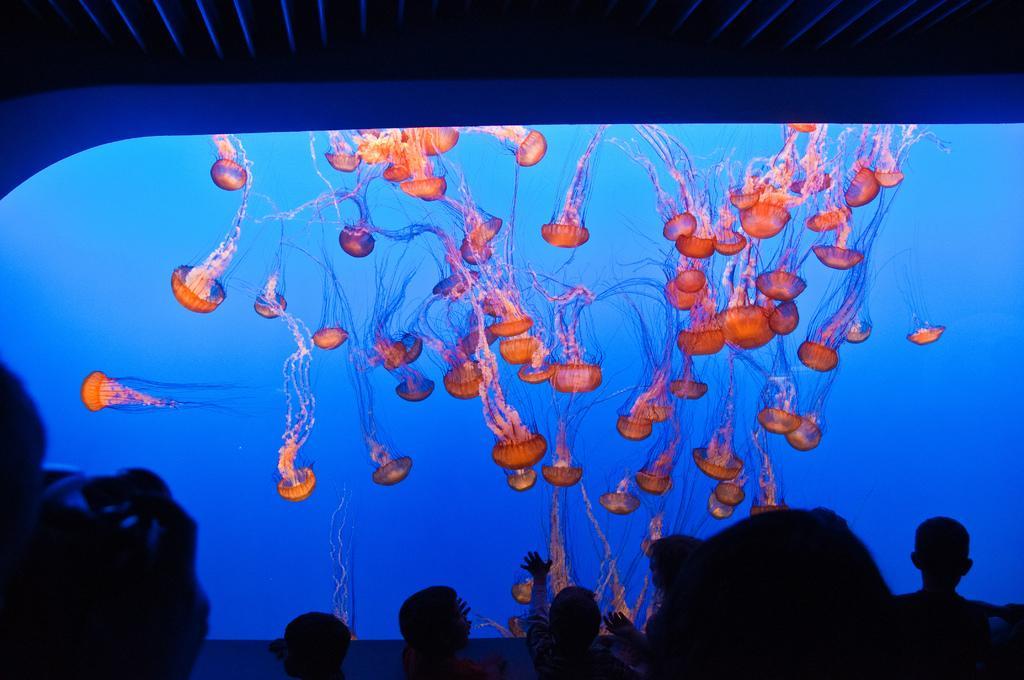Describe this image in one or two sentences. The image is clicked in a theater. At the bottom there are people. In the center of the picture it is screen, in the screen there are jellyfish. At the top it is ceiling. 